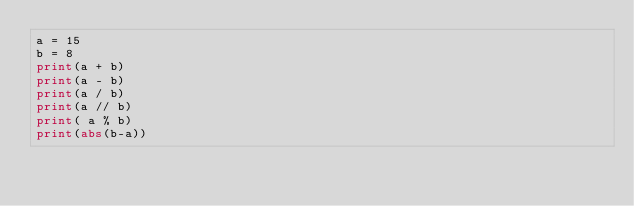Convert code to text. <code><loc_0><loc_0><loc_500><loc_500><_Python_>a = 15
b = 8
print(a + b)
print(a - b)
print(a / b)
print(a // b)
print( a % b)
print(abs(b-a))</code> 